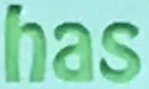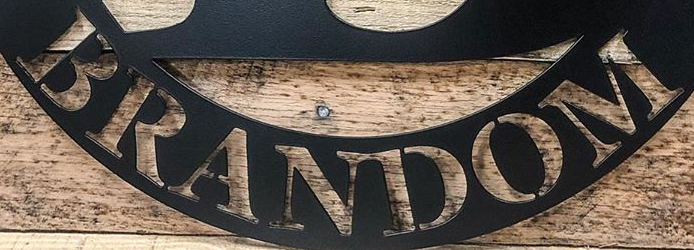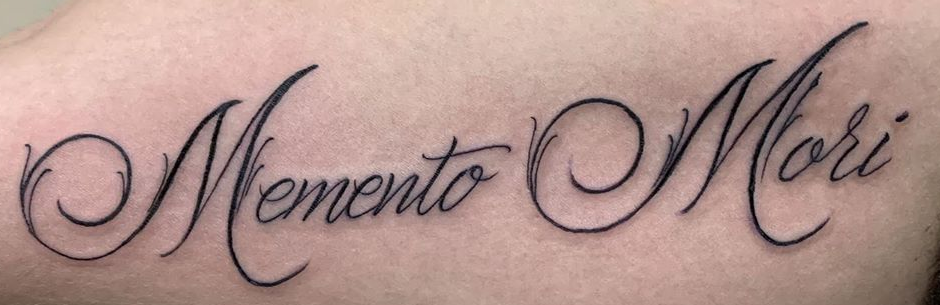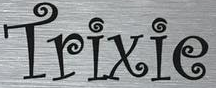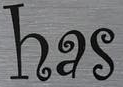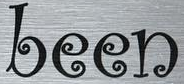Read the text from these images in sequence, separated by a semicolon. has; BRANDOM; MementoMori; Trixie; has; been 